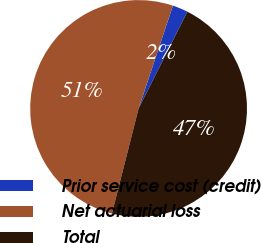Convert chart. <chart><loc_0><loc_0><loc_500><loc_500><pie_chart><fcel>Prior service cost (credit)<fcel>Net actuarial loss<fcel>Total<nl><fcel>2.31%<fcel>51.17%<fcel>46.52%<nl></chart> 